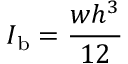Convert formula to latex. <formula><loc_0><loc_0><loc_500><loc_500>I _ { b } = \frac { w h ^ { 3 } } { 1 2 }</formula> 